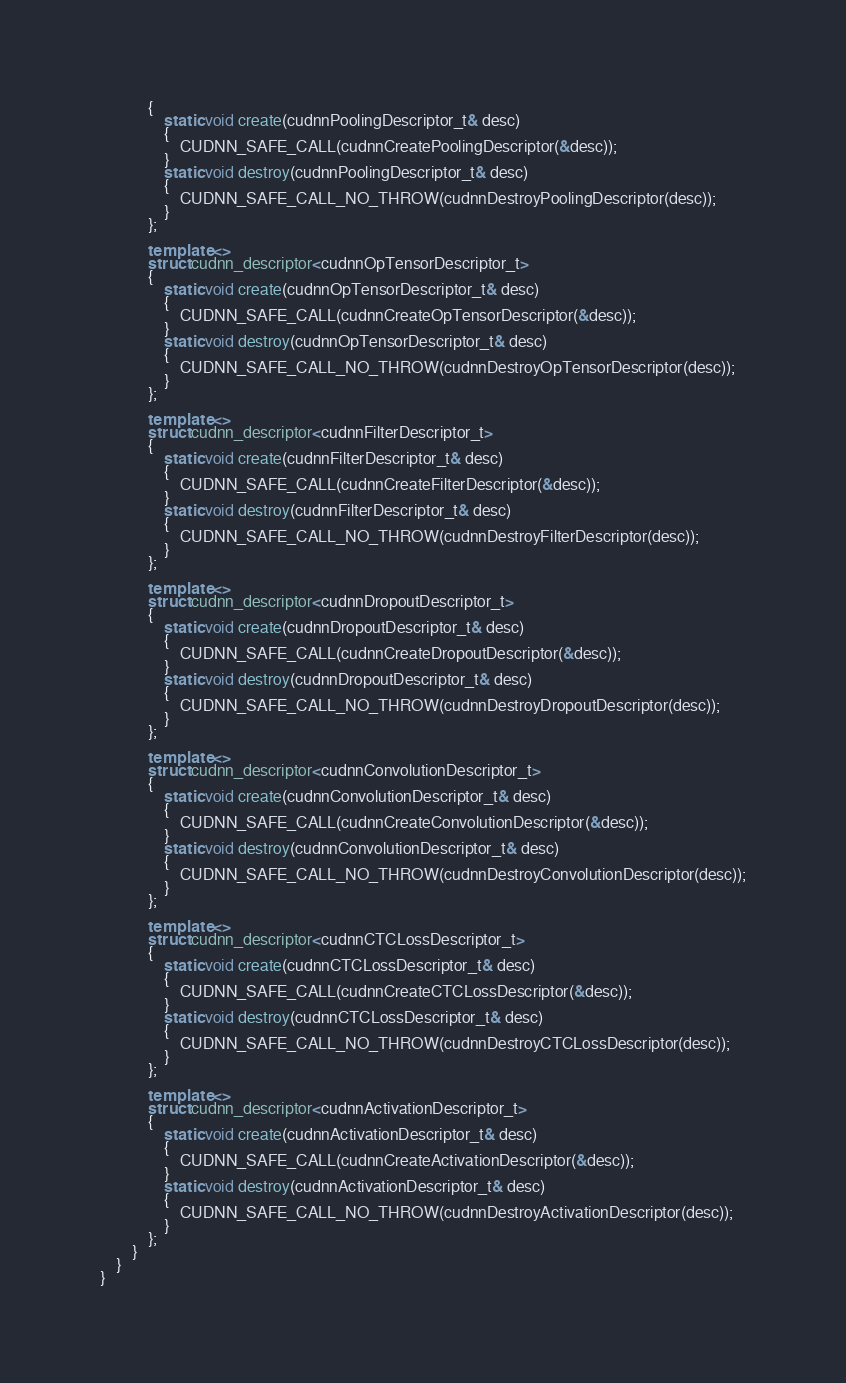<code> <loc_0><loc_0><loc_500><loc_500><_C++_>            {
                static void create(cudnnPoolingDescriptor_t& desc)
                {
                    CUDNN_SAFE_CALL(cudnnCreatePoolingDescriptor(&desc));
                }
                static void destroy(cudnnPoolingDescriptor_t& desc)
                {
                    CUDNN_SAFE_CALL_NO_THROW(cudnnDestroyPoolingDescriptor(desc));
                }
            };

            template <>
            struct cudnn_descriptor<cudnnOpTensorDescriptor_t>
            {
                static void create(cudnnOpTensorDescriptor_t& desc)
                {
                    CUDNN_SAFE_CALL(cudnnCreateOpTensorDescriptor(&desc));
                }
                static void destroy(cudnnOpTensorDescriptor_t& desc)
                {
                    CUDNN_SAFE_CALL_NO_THROW(cudnnDestroyOpTensorDescriptor(desc));
                }
            };

            template <>
            struct cudnn_descriptor<cudnnFilterDescriptor_t>
            {
                static void create(cudnnFilterDescriptor_t& desc)
                {
                    CUDNN_SAFE_CALL(cudnnCreateFilterDescriptor(&desc));
                }
                static void destroy(cudnnFilterDescriptor_t& desc)
                {
                    CUDNN_SAFE_CALL_NO_THROW(cudnnDestroyFilterDescriptor(desc));
                }
            };

            template <>
            struct cudnn_descriptor<cudnnDropoutDescriptor_t>
            {
                static void create(cudnnDropoutDescriptor_t& desc)
                {
                    CUDNN_SAFE_CALL(cudnnCreateDropoutDescriptor(&desc));
                }
                static void destroy(cudnnDropoutDescriptor_t& desc)
                {
                    CUDNN_SAFE_CALL_NO_THROW(cudnnDestroyDropoutDescriptor(desc));
                }
            };

            template <>
            struct cudnn_descriptor<cudnnConvolutionDescriptor_t>
            {
                static void create(cudnnConvolutionDescriptor_t& desc)
                {
                    CUDNN_SAFE_CALL(cudnnCreateConvolutionDescriptor(&desc));
                }
                static void destroy(cudnnConvolutionDescriptor_t& desc)
                {
                    CUDNN_SAFE_CALL_NO_THROW(cudnnDestroyConvolutionDescriptor(desc));
                }
            };

            template <>
            struct cudnn_descriptor<cudnnCTCLossDescriptor_t>
            {
                static void create(cudnnCTCLossDescriptor_t& desc)
                {
                    CUDNN_SAFE_CALL(cudnnCreateCTCLossDescriptor(&desc));
                }
                static void destroy(cudnnCTCLossDescriptor_t& desc)
                {
                    CUDNN_SAFE_CALL_NO_THROW(cudnnDestroyCTCLossDescriptor(desc));
                }
            };

            template <>
            struct cudnn_descriptor<cudnnActivationDescriptor_t>
            {
                static void create(cudnnActivationDescriptor_t& desc)
                {
                    CUDNN_SAFE_CALL(cudnnCreateActivationDescriptor(&desc));
                }
                static void destroy(cudnnActivationDescriptor_t& desc)
                {
                    CUDNN_SAFE_CALL_NO_THROW(cudnnDestroyActivationDescriptor(desc));
                }
            };
        }
    }
}
</code> 